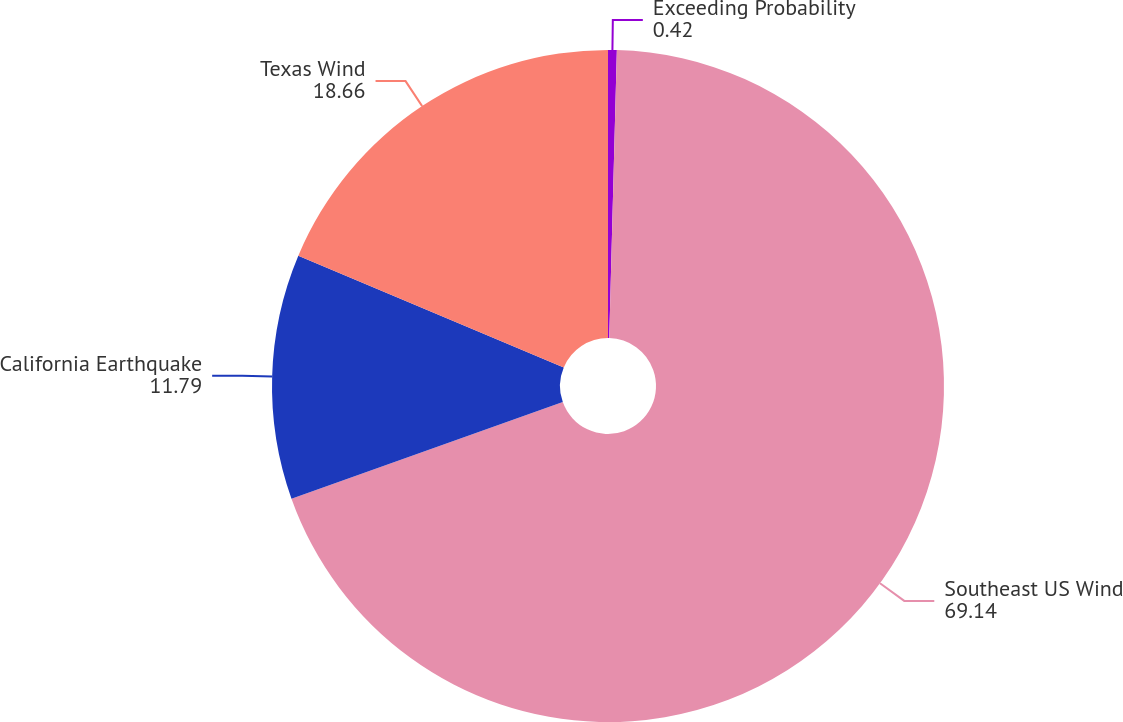<chart> <loc_0><loc_0><loc_500><loc_500><pie_chart><fcel>Exceeding Probability<fcel>Southeast US Wind<fcel>California Earthquake<fcel>Texas Wind<nl><fcel>0.42%<fcel>69.14%<fcel>11.79%<fcel>18.66%<nl></chart> 